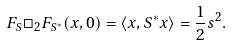Convert formula to latex. <formula><loc_0><loc_0><loc_500><loc_500>F _ { S } \Box _ { 2 } F _ { S ^ { * } } ( x , 0 ) = \langle x , S ^ { * } x \rangle = \frac { 1 } { 2 } s ^ { 2 } .</formula> 